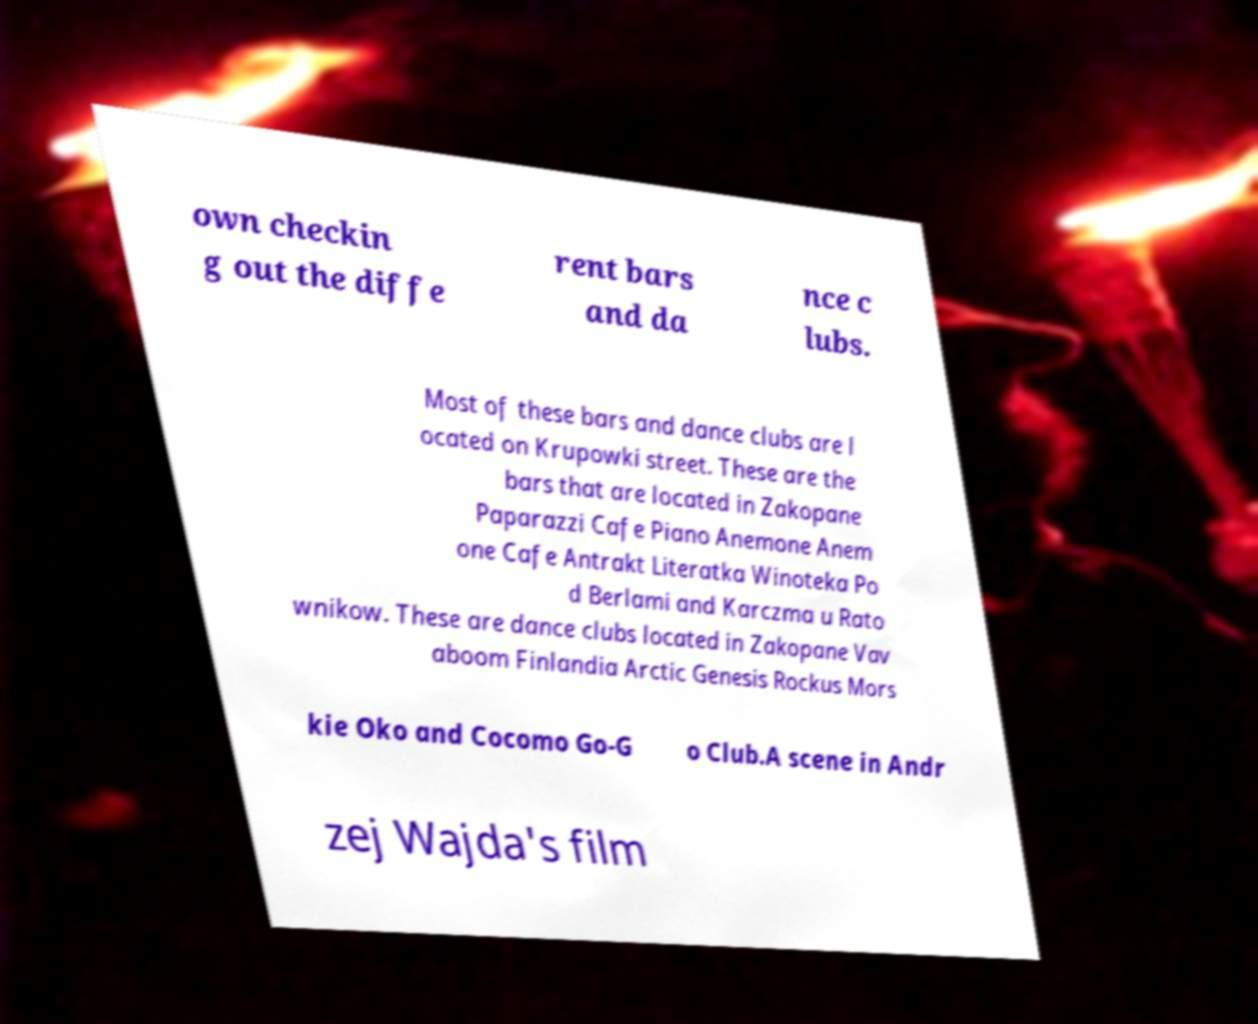Please read and relay the text visible in this image. What does it say? own checkin g out the diffe rent bars and da nce c lubs. Most of these bars and dance clubs are l ocated on Krupowki street. These are the bars that are located in Zakopane Paparazzi Cafe Piano Anemone Anem one Cafe Antrakt Literatka Winoteka Po d Berlami and Karczma u Rato wnikow. These are dance clubs located in Zakopane Vav aboom Finlandia Arctic Genesis Rockus Mors kie Oko and Cocomo Go-G o Club.A scene in Andr zej Wajda's film 